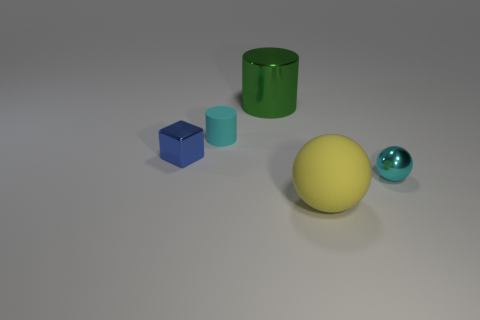Subtract all green spheres. Subtract all brown cylinders. How many spheres are left? 2 Add 3 big blue spheres. How many objects exist? 8 Subtract all spheres. How many objects are left? 3 Add 5 tiny cylinders. How many tiny cylinders exist? 6 Subtract 0 brown spheres. How many objects are left? 5 Subtract all tiny cyan things. Subtract all big cyan things. How many objects are left? 3 Add 5 rubber balls. How many rubber balls are left? 6 